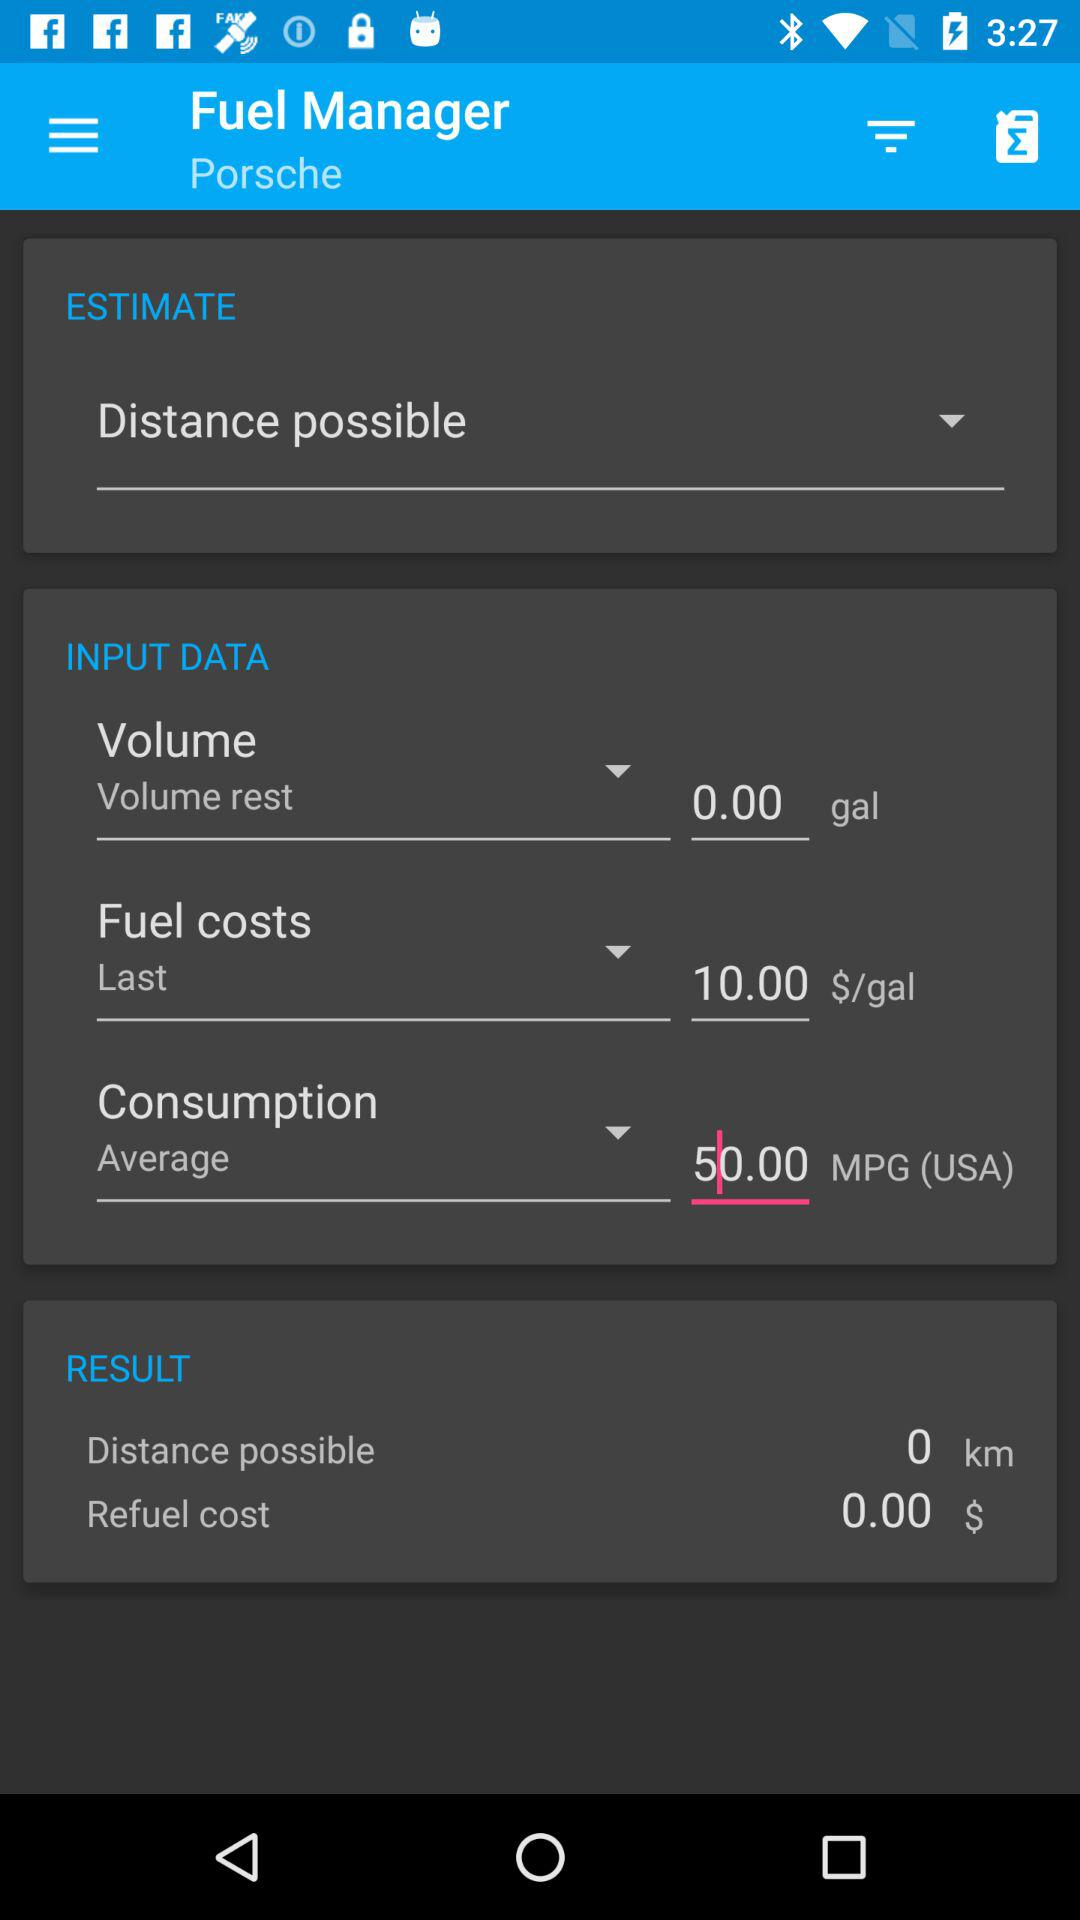What is the application name? The application name is "Fuel Manager". 